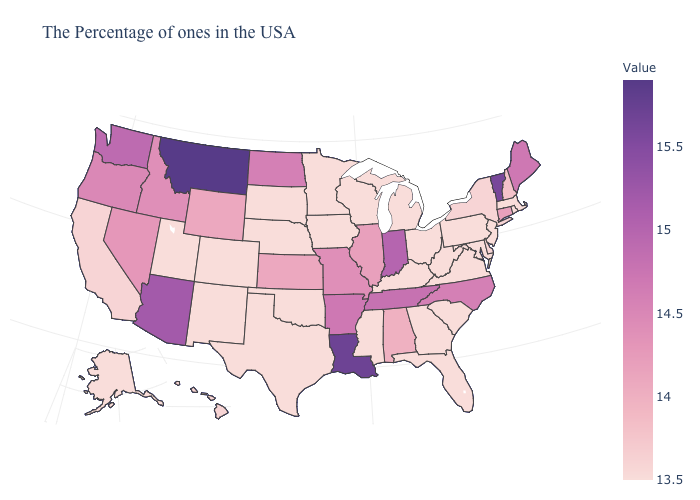Does the map have missing data?
Keep it brief. No. Does New Jersey have the lowest value in the USA?
Answer briefly. Yes. Does New York have the highest value in the USA?
Answer briefly. No. Among the states that border Kansas , which have the lowest value?
Write a very short answer. Nebraska, Oklahoma, Colorado. Among the states that border Kentucky , does Tennessee have the highest value?
Short answer required. No. 